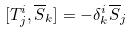<formula> <loc_0><loc_0><loc_500><loc_500>[ T _ { j } ^ { i } , \overline { S } _ { k } ] = - \delta _ { k } ^ { i } \overline { S } _ { j }</formula> 